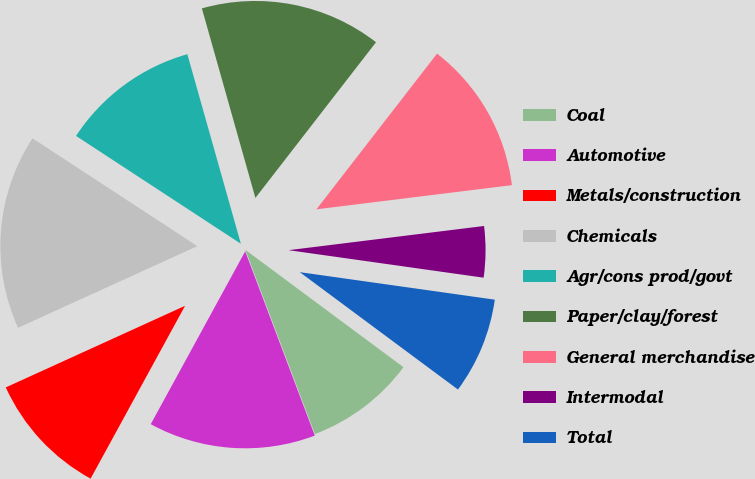<chart> <loc_0><loc_0><loc_500><loc_500><pie_chart><fcel>Coal<fcel>Automotive<fcel>Metals/construction<fcel>Chemicals<fcel>Agr/cons prod/govt<fcel>Paper/clay/forest<fcel>General merchandise<fcel>Intermodal<fcel>Total<nl><fcel>9.09%<fcel>13.71%<fcel>10.24%<fcel>16.02%<fcel>11.4%<fcel>14.87%<fcel>12.55%<fcel>4.19%<fcel>7.93%<nl></chart> 